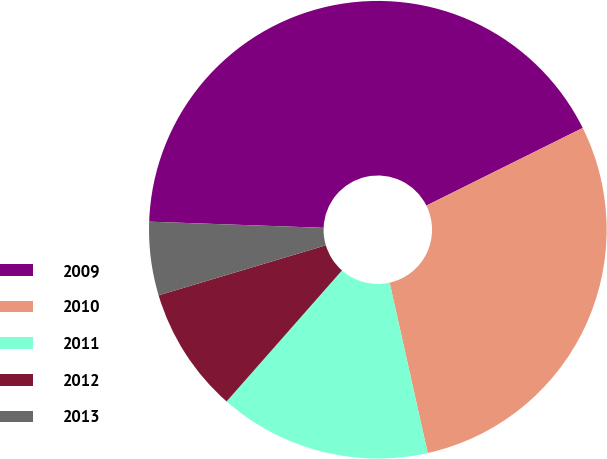Convert chart. <chart><loc_0><loc_0><loc_500><loc_500><pie_chart><fcel>2009<fcel>2010<fcel>2011<fcel>2012<fcel>2013<nl><fcel>42.1%<fcel>28.84%<fcel>14.99%<fcel>8.88%<fcel>5.19%<nl></chart> 